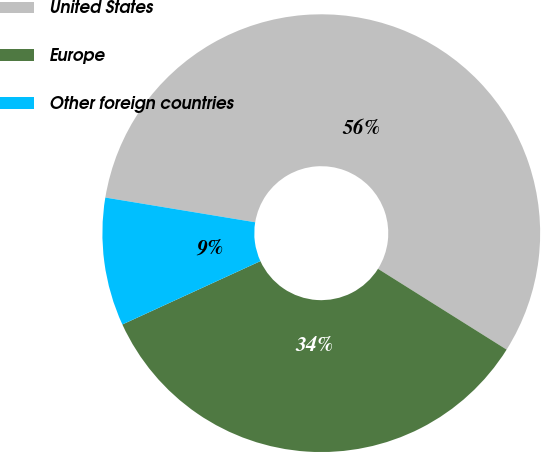Convert chart to OTSL. <chart><loc_0><loc_0><loc_500><loc_500><pie_chart><fcel>United States<fcel>Europe<fcel>Other foreign countries<nl><fcel>56.32%<fcel>34.22%<fcel>9.45%<nl></chart> 